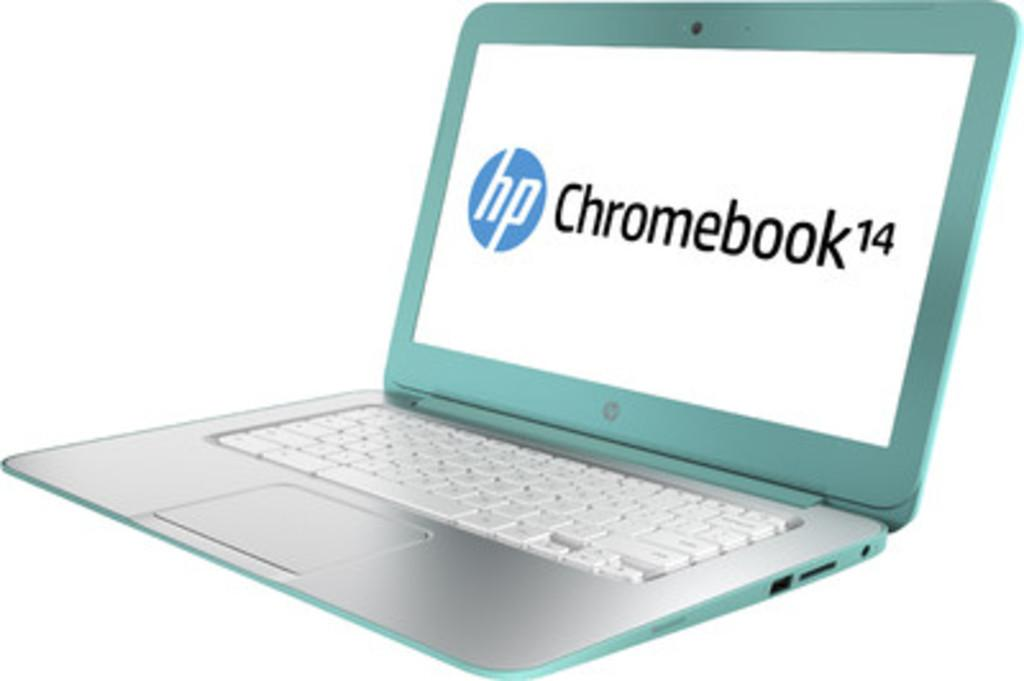<image>
Summarize the visual content of the image. A teal HP Chromebook is open in front of a white background. 